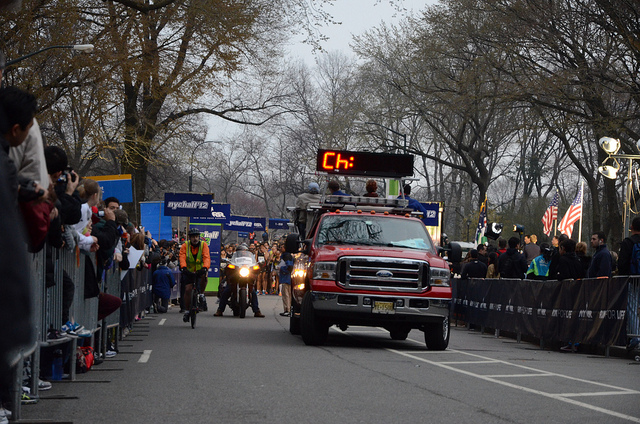Read all the text in this image. Ch: 